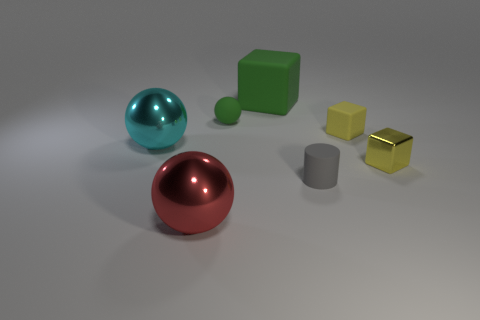What material is the block behind the tiny rubber object right of the tiny rubber cylinder?
Provide a succinct answer. Rubber. What number of other things have the same color as the small shiny object?
Your answer should be compact. 1. What shape is the small yellow thing that is the same material as the small gray cylinder?
Make the answer very short. Cube. There is a thing behind the green rubber ball; what is its size?
Provide a short and direct response. Large. Is the number of small rubber blocks that are to the left of the gray matte object the same as the number of big green blocks that are in front of the large cyan metal object?
Your answer should be compact. Yes. There is a small rubber object that is behind the rubber block that is right of the block on the left side of the cylinder; what color is it?
Make the answer very short. Green. What number of objects are both in front of the large cyan thing and right of the big red object?
Make the answer very short. 2. There is a large metallic thing that is in front of the small gray rubber cylinder; does it have the same color as the thing that is on the left side of the red shiny object?
Your answer should be compact. No. There is a green thing that is the same shape as the red metallic object; what size is it?
Ensure brevity in your answer.  Small. There is a big red object; are there any tiny gray rubber cylinders on the left side of it?
Your answer should be very brief. No. 